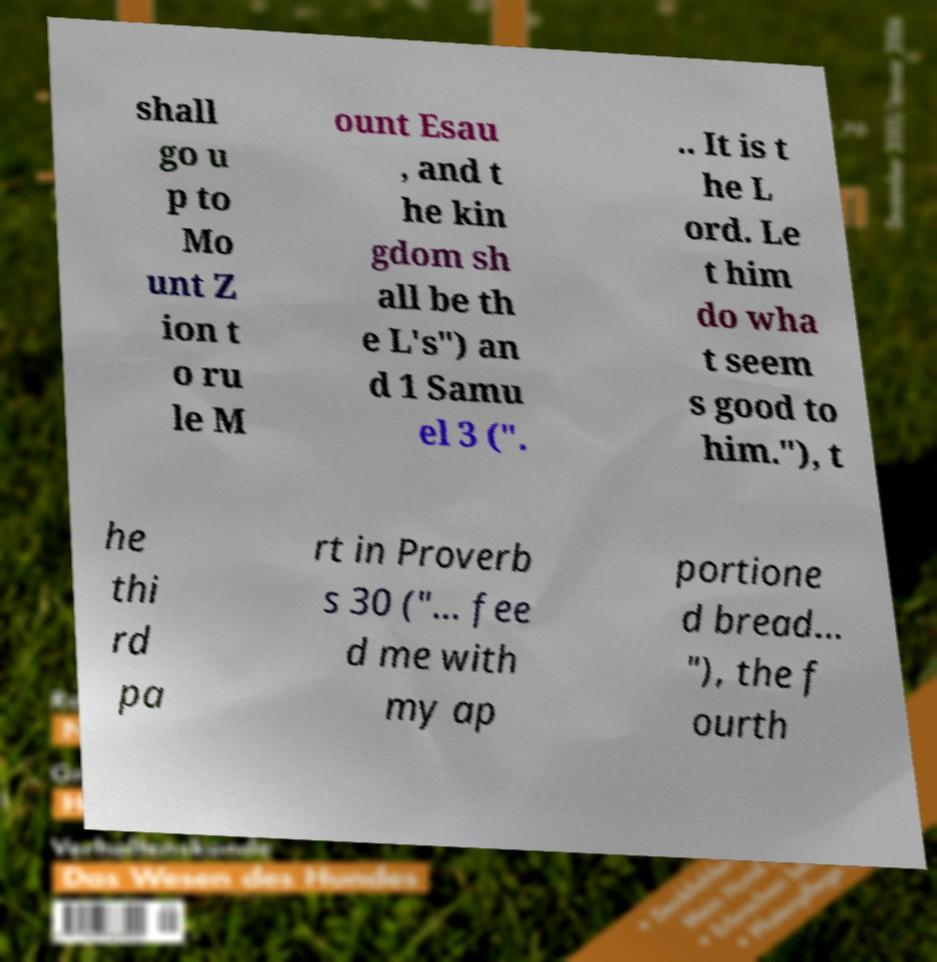Please identify and transcribe the text found in this image. shall go u p to Mo unt Z ion t o ru le M ount Esau , and t he kin gdom sh all be th e L's") an d 1 Samu el 3 (". .. It is t he L ord. Le t him do wha t seem s good to him."), t he thi rd pa rt in Proverb s 30 ("... fee d me with my ap portione d bread... "), the f ourth 